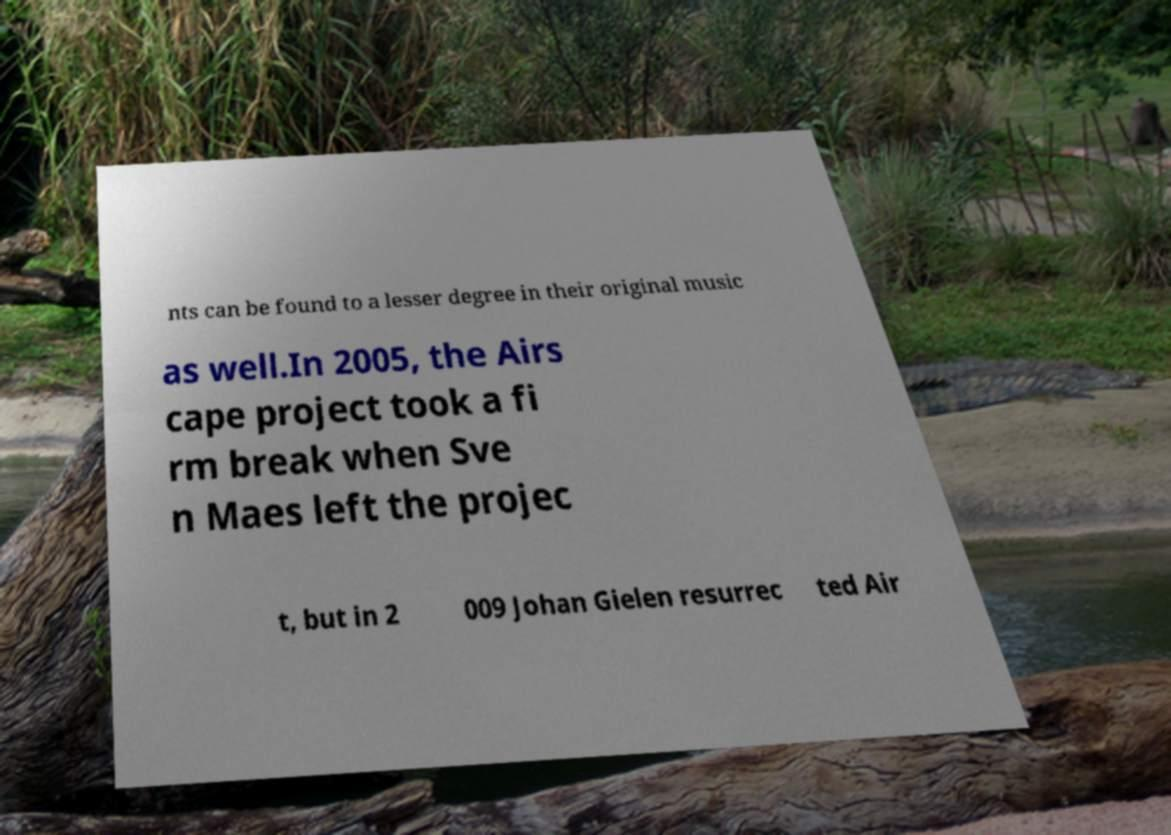Can you read and provide the text displayed in the image?This photo seems to have some interesting text. Can you extract and type it out for me? nts can be found to a lesser degree in their original music as well.In 2005, the Airs cape project took a fi rm break when Sve n Maes left the projec t, but in 2 009 Johan Gielen resurrec ted Air 